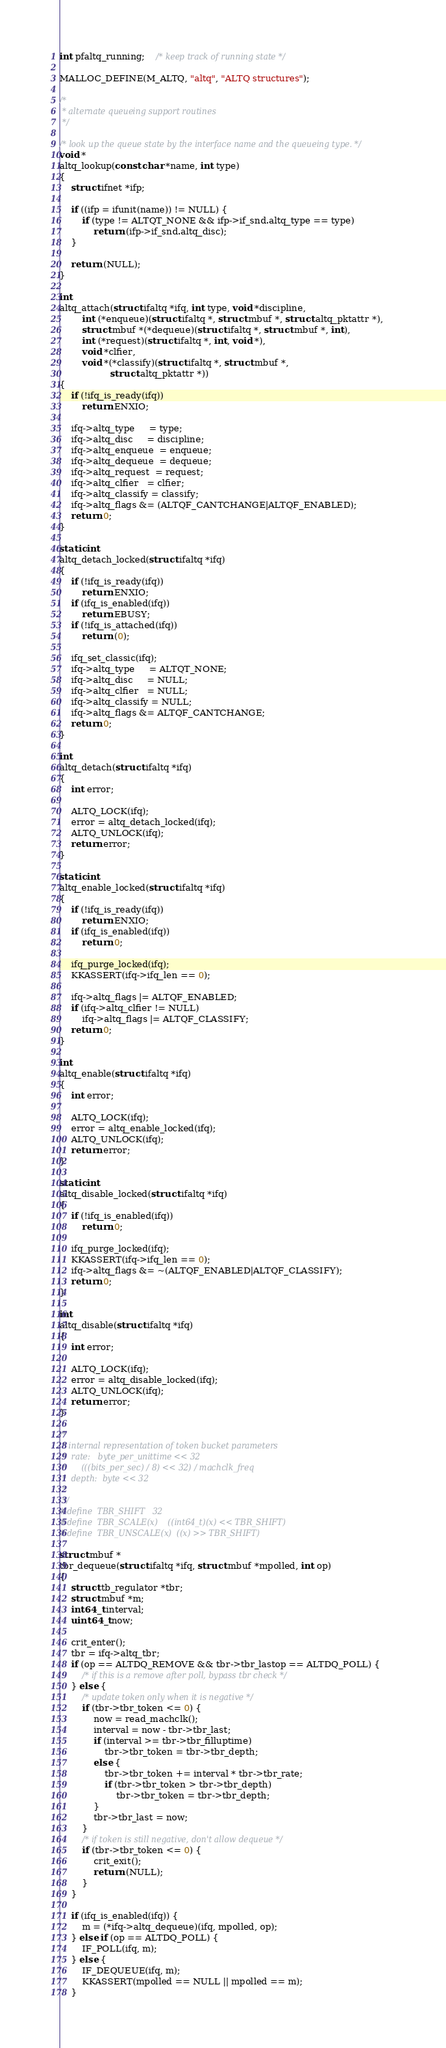<code> <loc_0><loc_0><loc_500><loc_500><_C_>
int pfaltq_running;	/* keep track of running state */

MALLOC_DEFINE(M_ALTQ, "altq", "ALTQ structures");

/*
 * alternate queueing support routines
 */

/* look up the queue state by the interface name and the queueing type. */
void *
altq_lookup(const char *name, int type)
{
	struct ifnet *ifp;

	if ((ifp = ifunit(name)) != NULL) {
		if (type != ALTQT_NONE && ifp->if_snd.altq_type == type)
			return (ifp->if_snd.altq_disc);
	}

	return (NULL);
}

int
altq_attach(struct ifaltq *ifq, int type, void *discipline,
	    int (*enqueue)(struct ifaltq *, struct mbuf *, struct altq_pktattr *),
	    struct mbuf *(*dequeue)(struct ifaltq *, struct mbuf *, int),
	    int (*request)(struct ifaltq *, int, void *),
	    void *clfier,
	    void *(*classify)(struct ifaltq *, struct mbuf *,
			      struct altq_pktattr *))
{
	if (!ifq_is_ready(ifq))
		return ENXIO;

	ifq->altq_type     = type;
	ifq->altq_disc     = discipline;
	ifq->altq_enqueue  = enqueue;
	ifq->altq_dequeue  = dequeue;
	ifq->altq_request  = request;
	ifq->altq_clfier   = clfier;
	ifq->altq_classify = classify;
	ifq->altq_flags &= (ALTQF_CANTCHANGE|ALTQF_ENABLED);
	return 0;
}

static int
altq_detach_locked(struct ifaltq *ifq)
{
	if (!ifq_is_ready(ifq))
		return ENXIO;
	if (ifq_is_enabled(ifq))
		return EBUSY;
	if (!ifq_is_attached(ifq))
		return (0);

	ifq_set_classic(ifq);
	ifq->altq_type     = ALTQT_NONE;
	ifq->altq_disc     = NULL;
	ifq->altq_clfier   = NULL;
	ifq->altq_classify = NULL;
	ifq->altq_flags &= ALTQF_CANTCHANGE;
	return 0;
}

int
altq_detach(struct ifaltq *ifq)
{
	int error;

	ALTQ_LOCK(ifq);
	error = altq_detach_locked(ifq);
	ALTQ_UNLOCK(ifq);
	return error;
}

static int
altq_enable_locked(struct ifaltq *ifq)
{
	if (!ifq_is_ready(ifq))
		return ENXIO;
	if (ifq_is_enabled(ifq))
		return 0;

	ifq_purge_locked(ifq);
	KKASSERT(ifq->ifq_len == 0);

	ifq->altq_flags |= ALTQF_ENABLED;
	if (ifq->altq_clfier != NULL)
		ifq->altq_flags |= ALTQF_CLASSIFY;
	return 0;
}

int
altq_enable(struct ifaltq *ifq)
{
	int error;

	ALTQ_LOCK(ifq);
	error = altq_enable_locked(ifq);
	ALTQ_UNLOCK(ifq);
	return error;
}

static int
altq_disable_locked(struct ifaltq *ifq)
{
	if (!ifq_is_enabled(ifq))
		return 0;

	ifq_purge_locked(ifq);
	KKASSERT(ifq->ifq_len == 0);
	ifq->altq_flags &= ~(ALTQF_ENABLED|ALTQF_CLASSIFY);
	return 0;
}

int
altq_disable(struct ifaltq *ifq)
{
	int error;

	ALTQ_LOCK(ifq);
	error = altq_disable_locked(ifq);
	ALTQ_UNLOCK(ifq);
	return error;
}

/*
 * internal representation of token bucket parameters
 *	rate:	byte_per_unittime << 32
 *		(((bits_per_sec) / 8) << 32) / machclk_freq
 *	depth:	byte << 32
 *
 */
#define	TBR_SHIFT	32
#define	TBR_SCALE(x)	((int64_t)(x) << TBR_SHIFT)
#define	TBR_UNSCALE(x)	((x) >> TBR_SHIFT)

struct mbuf *
tbr_dequeue(struct ifaltq *ifq, struct mbuf *mpolled, int op)
{
	struct tb_regulator *tbr;
	struct mbuf *m;
	int64_t interval;
	uint64_t now;

	crit_enter();
	tbr = ifq->altq_tbr;
	if (op == ALTDQ_REMOVE && tbr->tbr_lastop == ALTDQ_POLL) {
		/* if this is a remove after poll, bypass tbr check */
	} else {
		/* update token only when it is negative */
		if (tbr->tbr_token <= 0) {
			now = read_machclk();
			interval = now - tbr->tbr_last;
			if (interval >= tbr->tbr_filluptime)
				tbr->tbr_token = tbr->tbr_depth;
			else {
				tbr->tbr_token += interval * tbr->tbr_rate;
				if (tbr->tbr_token > tbr->tbr_depth)
					tbr->tbr_token = tbr->tbr_depth;
			}
			tbr->tbr_last = now;
		}
		/* if token is still negative, don't allow dequeue */
		if (tbr->tbr_token <= 0) {
			crit_exit();
			return (NULL);
		}
	}

	if (ifq_is_enabled(ifq)) {
		m = (*ifq->altq_dequeue)(ifq, mpolled, op);
	} else if (op == ALTDQ_POLL) {
		IF_POLL(ifq, m);
	} else {
		IF_DEQUEUE(ifq, m);
		KKASSERT(mpolled == NULL || mpolled == m);
	}
</code> 